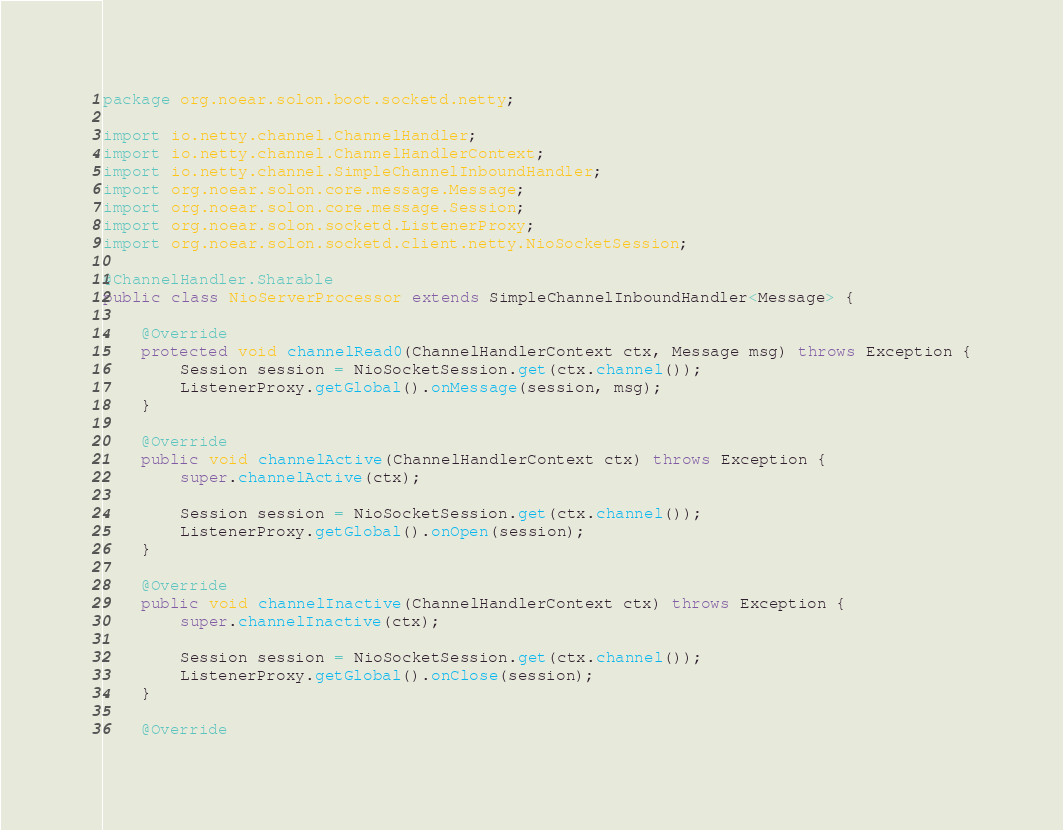Convert code to text. <code><loc_0><loc_0><loc_500><loc_500><_Java_>package org.noear.solon.boot.socketd.netty;

import io.netty.channel.ChannelHandler;
import io.netty.channel.ChannelHandlerContext;
import io.netty.channel.SimpleChannelInboundHandler;
import org.noear.solon.core.message.Message;
import org.noear.solon.core.message.Session;
import org.noear.solon.socketd.ListenerProxy;
import org.noear.solon.socketd.client.netty.NioSocketSession;

@ChannelHandler.Sharable
public class NioServerProcessor extends SimpleChannelInboundHandler<Message> {

    @Override
    protected void channelRead0(ChannelHandlerContext ctx, Message msg) throws Exception {
        Session session = NioSocketSession.get(ctx.channel());
        ListenerProxy.getGlobal().onMessage(session, msg);
    }

    @Override
    public void channelActive(ChannelHandlerContext ctx) throws Exception {
        super.channelActive(ctx);

        Session session = NioSocketSession.get(ctx.channel());
        ListenerProxy.getGlobal().onOpen(session);
    }

    @Override
    public void channelInactive(ChannelHandlerContext ctx) throws Exception {
        super.channelInactive(ctx);

        Session session = NioSocketSession.get(ctx.channel());
        ListenerProxy.getGlobal().onClose(session);
    }

    @Override</code> 